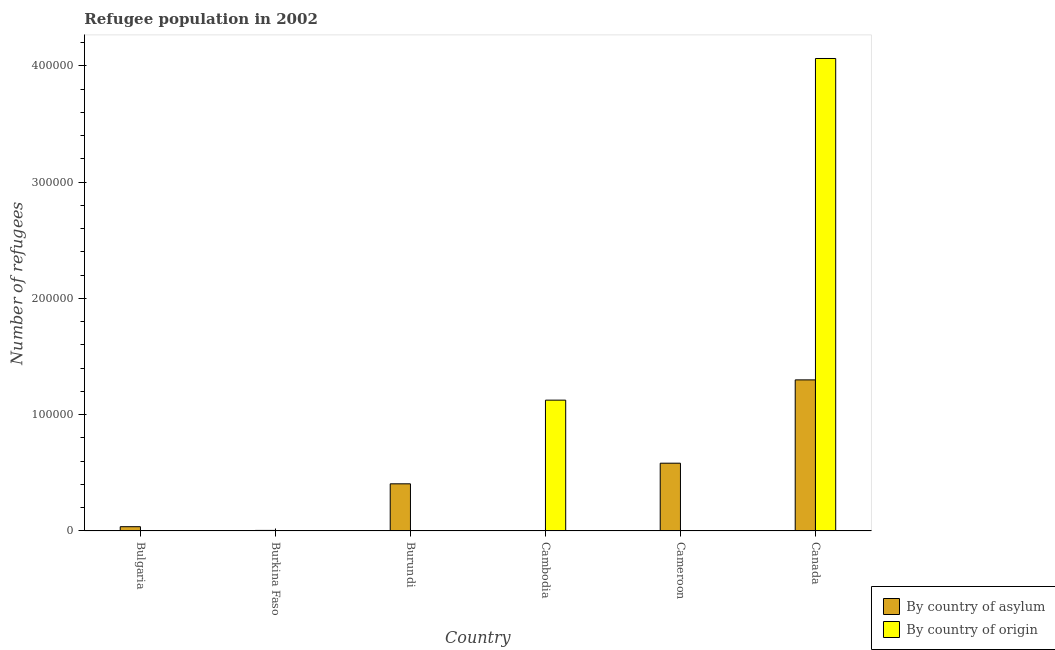What is the label of the 3rd group of bars from the left?
Keep it short and to the point. Burundi. What is the number of refugees by country of asylum in Canada?
Give a very brief answer. 1.30e+05. Across all countries, what is the maximum number of refugees by country of origin?
Offer a terse response. 4.06e+05. Across all countries, what is the minimum number of refugees by country of asylum?
Your answer should be compact. 200. In which country was the number of refugees by country of origin maximum?
Provide a short and direct response. Canada. What is the total number of refugees by country of asylum in the graph?
Provide a succinct answer. 2.33e+05. What is the difference between the number of refugees by country of origin in Burkina Faso and that in Cambodia?
Give a very brief answer. -1.12e+05. What is the difference between the number of refugees by country of origin in Cambodia and the number of refugees by country of asylum in Bulgaria?
Your answer should be very brief. 1.09e+05. What is the average number of refugees by country of origin per country?
Keep it short and to the point. 8.66e+04. What is the difference between the number of refugees by country of asylum and number of refugees by country of origin in Cameroon?
Offer a very short reply. 5.81e+04. What is the ratio of the number of refugees by country of asylum in Burkina Faso to that in Cambodia?
Ensure brevity in your answer.  2.29. What is the difference between the highest and the second highest number of refugees by country of origin?
Your answer should be very brief. 2.94e+05. What is the difference between the highest and the lowest number of refugees by country of origin?
Offer a very short reply. 4.06e+05. In how many countries, is the number of refugees by country of origin greater than the average number of refugees by country of origin taken over all countries?
Your answer should be compact. 2. What does the 1st bar from the left in Bulgaria represents?
Provide a succinct answer. By country of asylum. What does the 2nd bar from the right in Burkina Faso represents?
Provide a succinct answer. By country of asylum. How many bars are there?
Make the answer very short. 12. Are all the bars in the graph horizontal?
Keep it short and to the point. No. How many countries are there in the graph?
Your answer should be very brief. 6. Does the graph contain grids?
Your answer should be compact. No. How many legend labels are there?
Your answer should be compact. 2. How are the legend labels stacked?
Provide a short and direct response. Vertical. What is the title of the graph?
Offer a very short reply. Refugee population in 2002. What is the label or title of the X-axis?
Keep it short and to the point. Country. What is the label or title of the Y-axis?
Offer a very short reply. Number of refugees. What is the Number of refugees in By country of asylum in Bulgaria?
Give a very brief answer. 3658. What is the Number of refugees in By country of asylum in Burkina Faso?
Provide a short and direct response. 457. What is the Number of refugees of By country of origin in Burkina Faso?
Your response must be concise. 232. What is the Number of refugees of By country of asylum in Burundi?
Provide a short and direct response. 4.05e+04. What is the Number of refugees in By country of asylum in Cambodia?
Ensure brevity in your answer.  200. What is the Number of refugees in By country of origin in Cambodia?
Give a very brief answer. 1.13e+05. What is the Number of refugees of By country of asylum in Cameroon?
Offer a very short reply. 5.83e+04. What is the Number of refugees of By country of origin in Cameroon?
Make the answer very short. 219. What is the Number of refugees of By country of asylum in Canada?
Ensure brevity in your answer.  1.30e+05. What is the Number of refugees in By country of origin in Canada?
Provide a succinct answer. 4.06e+05. Across all countries, what is the maximum Number of refugees of By country of asylum?
Ensure brevity in your answer.  1.30e+05. Across all countries, what is the maximum Number of refugees in By country of origin?
Provide a short and direct response. 4.06e+05. Across all countries, what is the minimum Number of refugees of By country of origin?
Your response must be concise. 1. What is the total Number of refugees in By country of asylum in the graph?
Keep it short and to the point. 2.33e+05. What is the total Number of refugees in By country of origin in the graph?
Ensure brevity in your answer.  5.19e+05. What is the difference between the Number of refugees of By country of asylum in Bulgaria and that in Burkina Faso?
Make the answer very short. 3201. What is the difference between the Number of refugees in By country of origin in Bulgaria and that in Burkina Faso?
Give a very brief answer. -231. What is the difference between the Number of refugees in By country of asylum in Bulgaria and that in Burundi?
Your response must be concise. -3.69e+04. What is the difference between the Number of refugees in By country of origin in Bulgaria and that in Burundi?
Your response must be concise. 0. What is the difference between the Number of refugees of By country of asylum in Bulgaria and that in Cambodia?
Keep it short and to the point. 3458. What is the difference between the Number of refugees in By country of origin in Bulgaria and that in Cambodia?
Offer a very short reply. -1.13e+05. What is the difference between the Number of refugees of By country of asylum in Bulgaria and that in Cameroon?
Provide a succinct answer. -5.46e+04. What is the difference between the Number of refugees in By country of origin in Bulgaria and that in Cameroon?
Provide a succinct answer. -218. What is the difference between the Number of refugees of By country of asylum in Bulgaria and that in Canada?
Keep it short and to the point. -1.26e+05. What is the difference between the Number of refugees in By country of origin in Bulgaria and that in Canada?
Make the answer very short. -4.06e+05. What is the difference between the Number of refugees in By country of asylum in Burkina Faso and that in Burundi?
Your answer should be very brief. -4.01e+04. What is the difference between the Number of refugees of By country of origin in Burkina Faso and that in Burundi?
Your answer should be very brief. 231. What is the difference between the Number of refugees in By country of asylum in Burkina Faso and that in Cambodia?
Provide a succinct answer. 257. What is the difference between the Number of refugees in By country of origin in Burkina Faso and that in Cambodia?
Give a very brief answer. -1.12e+05. What is the difference between the Number of refugees in By country of asylum in Burkina Faso and that in Cameroon?
Offer a very short reply. -5.78e+04. What is the difference between the Number of refugees of By country of origin in Burkina Faso and that in Cameroon?
Keep it short and to the point. 13. What is the difference between the Number of refugees in By country of asylum in Burkina Faso and that in Canada?
Your response must be concise. -1.29e+05. What is the difference between the Number of refugees in By country of origin in Burkina Faso and that in Canada?
Keep it short and to the point. -4.06e+05. What is the difference between the Number of refugees in By country of asylum in Burundi and that in Cambodia?
Keep it short and to the point. 4.03e+04. What is the difference between the Number of refugees of By country of origin in Burundi and that in Cambodia?
Make the answer very short. -1.13e+05. What is the difference between the Number of refugees in By country of asylum in Burundi and that in Cameroon?
Give a very brief answer. -1.78e+04. What is the difference between the Number of refugees of By country of origin in Burundi and that in Cameroon?
Offer a terse response. -218. What is the difference between the Number of refugees in By country of asylum in Burundi and that in Canada?
Your answer should be very brief. -8.94e+04. What is the difference between the Number of refugees in By country of origin in Burundi and that in Canada?
Provide a succinct answer. -4.06e+05. What is the difference between the Number of refugees of By country of asylum in Cambodia and that in Cameroon?
Keep it short and to the point. -5.81e+04. What is the difference between the Number of refugees in By country of origin in Cambodia and that in Cameroon?
Give a very brief answer. 1.12e+05. What is the difference between the Number of refugees of By country of asylum in Cambodia and that in Canada?
Your answer should be very brief. -1.30e+05. What is the difference between the Number of refugees in By country of origin in Cambodia and that in Canada?
Ensure brevity in your answer.  -2.94e+05. What is the difference between the Number of refugees in By country of asylum in Cameroon and that in Canada?
Your response must be concise. -7.17e+04. What is the difference between the Number of refugees of By country of origin in Cameroon and that in Canada?
Provide a succinct answer. -4.06e+05. What is the difference between the Number of refugees of By country of asylum in Bulgaria and the Number of refugees of By country of origin in Burkina Faso?
Provide a short and direct response. 3426. What is the difference between the Number of refugees of By country of asylum in Bulgaria and the Number of refugees of By country of origin in Burundi?
Your answer should be very brief. 3657. What is the difference between the Number of refugees of By country of asylum in Bulgaria and the Number of refugees of By country of origin in Cambodia?
Keep it short and to the point. -1.09e+05. What is the difference between the Number of refugees of By country of asylum in Bulgaria and the Number of refugees of By country of origin in Cameroon?
Offer a very short reply. 3439. What is the difference between the Number of refugees of By country of asylum in Bulgaria and the Number of refugees of By country of origin in Canada?
Make the answer very short. -4.03e+05. What is the difference between the Number of refugees of By country of asylum in Burkina Faso and the Number of refugees of By country of origin in Burundi?
Provide a succinct answer. 456. What is the difference between the Number of refugees in By country of asylum in Burkina Faso and the Number of refugees in By country of origin in Cambodia?
Keep it short and to the point. -1.12e+05. What is the difference between the Number of refugees in By country of asylum in Burkina Faso and the Number of refugees in By country of origin in Cameroon?
Make the answer very short. 238. What is the difference between the Number of refugees in By country of asylum in Burkina Faso and the Number of refugees in By country of origin in Canada?
Provide a succinct answer. -4.06e+05. What is the difference between the Number of refugees in By country of asylum in Burundi and the Number of refugees in By country of origin in Cambodia?
Give a very brief answer. -7.20e+04. What is the difference between the Number of refugees in By country of asylum in Burundi and the Number of refugees in By country of origin in Cameroon?
Your response must be concise. 4.03e+04. What is the difference between the Number of refugees in By country of asylum in Burundi and the Number of refugees in By country of origin in Canada?
Make the answer very short. -3.66e+05. What is the difference between the Number of refugees of By country of asylum in Cambodia and the Number of refugees of By country of origin in Cameroon?
Give a very brief answer. -19. What is the difference between the Number of refugees of By country of asylum in Cambodia and the Number of refugees of By country of origin in Canada?
Keep it short and to the point. -4.06e+05. What is the difference between the Number of refugees in By country of asylum in Cameroon and the Number of refugees in By country of origin in Canada?
Make the answer very short. -3.48e+05. What is the average Number of refugees in By country of asylum per country?
Offer a terse response. 3.88e+04. What is the average Number of refugees of By country of origin per country?
Provide a succinct answer. 8.66e+04. What is the difference between the Number of refugees in By country of asylum and Number of refugees in By country of origin in Bulgaria?
Give a very brief answer. 3657. What is the difference between the Number of refugees of By country of asylum and Number of refugees of By country of origin in Burkina Faso?
Provide a short and direct response. 225. What is the difference between the Number of refugees in By country of asylum and Number of refugees in By country of origin in Burundi?
Provide a succinct answer. 4.05e+04. What is the difference between the Number of refugees of By country of asylum and Number of refugees of By country of origin in Cambodia?
Keep it short and to the point. -1.12e+05. What is the difference between the Number of refugees in By country of asylum and Number of refugees in By country of origin in Cameroon?
Offer a very short reply. 5.81e+04. What is the difference between the Number of refugees of By country of asylum and Number of refugees of By country of origin in Canada?
Give a very brief answer. -2.76e+05. What is the ratio of the Number of refugees of By country of asylum in Bulgaria to that in Burkina Faso?
Make the answer very short. 8. What is the ratio of the Number of refugees in By country of origin in Bulgaria to that in Burkina Faso?
Ensure brevity in your answer.  0. What is the ratio of the Number of refugees in By country of asylum in Bulgaria to that in Burundi?
Provide a succinct answer. 0.09. What is the ratio of the Number of refugees of By country of asylum in Bulgaria to that in Cambodia?
Your answer should be compact. 18.29. What is the ratio of the Number of refugees of By country of origin in Bulgaria to that in Cambodia?
Give a very brief answer. 0. What is the ratio of the Number of refugees in By country of asylum in Bulgaria to that in Cameroon?
Keep it short and to the point. 0.06. What is the ratio of the Number of refugees of By country of origin in Bulgaria to that in Cameroon?
Your answer should be compact. 0. What is the ratio of the Number of refugees in By country of asylum in Bulgaria to that in Canada?
Keep it short and to the point. 0.03. What is the ratio of the Number of refugees in By country of asylum in Burkina Faso to that in Burundi?
Give a very brief answer. 0.01. What is the ratio of the Number of refugees in By country of origin in Burkina Faso to that in Burundi?
Your response must be concise. 232. What is the ratio of the Number of refugees in By country of asylum in Burkina Faso to that in Cambodia?
Make the answer very short. 2.29. What is the ratio of the Number of refugees in By country of origin in Burkina Faso to that in Cambodia?
Provide a short and direct response. 0. What is the ratio of the Number of refugees in By country of asylum in Burkina Faso to that in Cameroon?
Your answer should be very brief. 0.01. What is the ratio of the Number of refugees of By country of origin in Burkina Faso to that in Cameroon?
Keep it short and to the point. 1.06. What is the ratio of the Number of refugees in By country of asylum in Burkina Faso to that in Canada?
Offer a terse response. 0. What is the ratio of the Number of refugees in By country of origin in Burkina Faso to that in Canada?
Your answer should be very brief. 0. What is the ratio of the Number of refugees in By country of asylum in Burundi to that in Cambodia?
Provide a short and direct response. 202.66. What is the ratio of the Number of refugees of By country of origin in Burundi to that in Cambodia?
Make the answer very short. 0. What is the ratio of the Number of refugees of By country of asylum in Burundi to that in Cameroon?
Keep it short and to the point. 0.7. What is the ratio of the Number of refugees in By country of origin in Burundi to that in Cameroon?
Provide a short and direct response. 0. What is the ratio of the Number of refugees of By country of asylum in Burundi to that in Canada?
Your answer should be very brief. 0.31. What is the ratio of the Number of refugees of By country of origin in Burundi to that in Canada?
Offer a very short reply. 0. What is the ratio of the Number of refugees of By country of asylum in Cambodia to that in Cameroon?
Ensure brevity in your answer.  0. What is the ratio of the Number of refugees of By country of origin in Cambodia to that in Cameroon?
Your answer should be very brief. 513.8. What is the ratio of the Number of refugees in By country of asylum in Cambodia to that in Canada?
Your answer should be compact. 0. What is the ratio of the Number of refugees in By country of origin in Cambodia to that in Canada?
Give a very brief answer. 0.28. What is the ratio of the Number of refugees in By country of asylum in Cameroon to that in Canada?
Your answer should be compact. 0.45. What is the difference between the highest and the second highest Number of refugees in By country of asylum?
Keep it short and to the point. 7.17e+04. What is the difference between the highest and the second highest Number of refugees in By country of origin?
Your answer should be compact. 2.94e+05. What is the difference between the highest and the lowest Number of refugees in By country of asylum?
Keep it short and to the point. 1.30e+05. What is the difference between the highest and the lowest Number of refugees in By country of origin?
Give a very brief answer. 4.06e+05. 